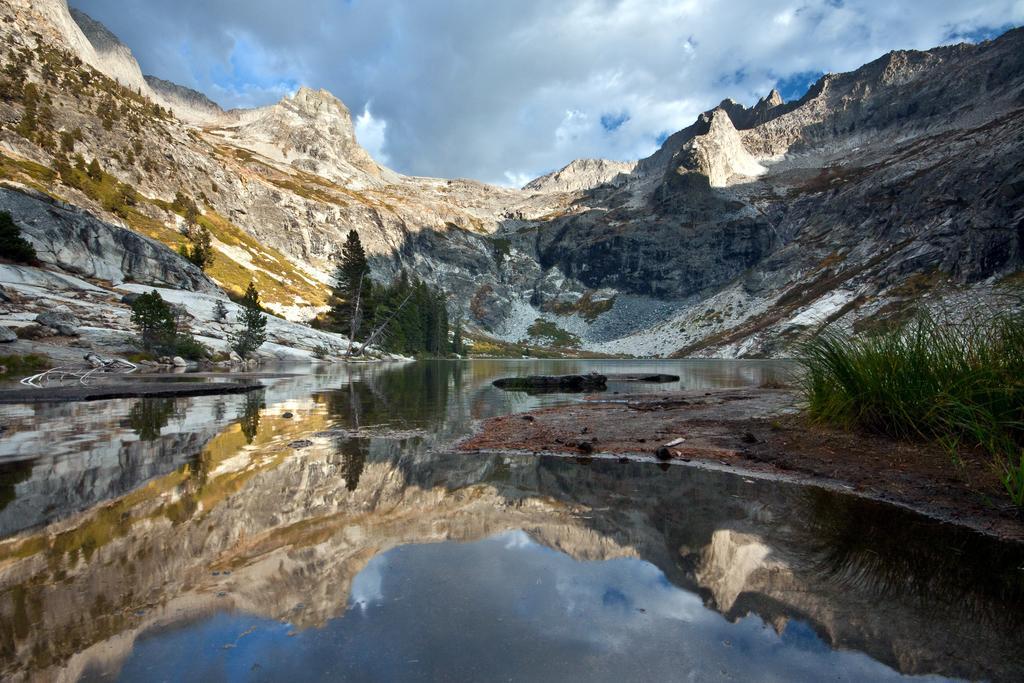Could you give a brief overview of what you see in this image? In this picture we can see there are trees, a lake, rocks and hills. On the right side of the image there is grass. Behind the hills where is the cloudy sky. 